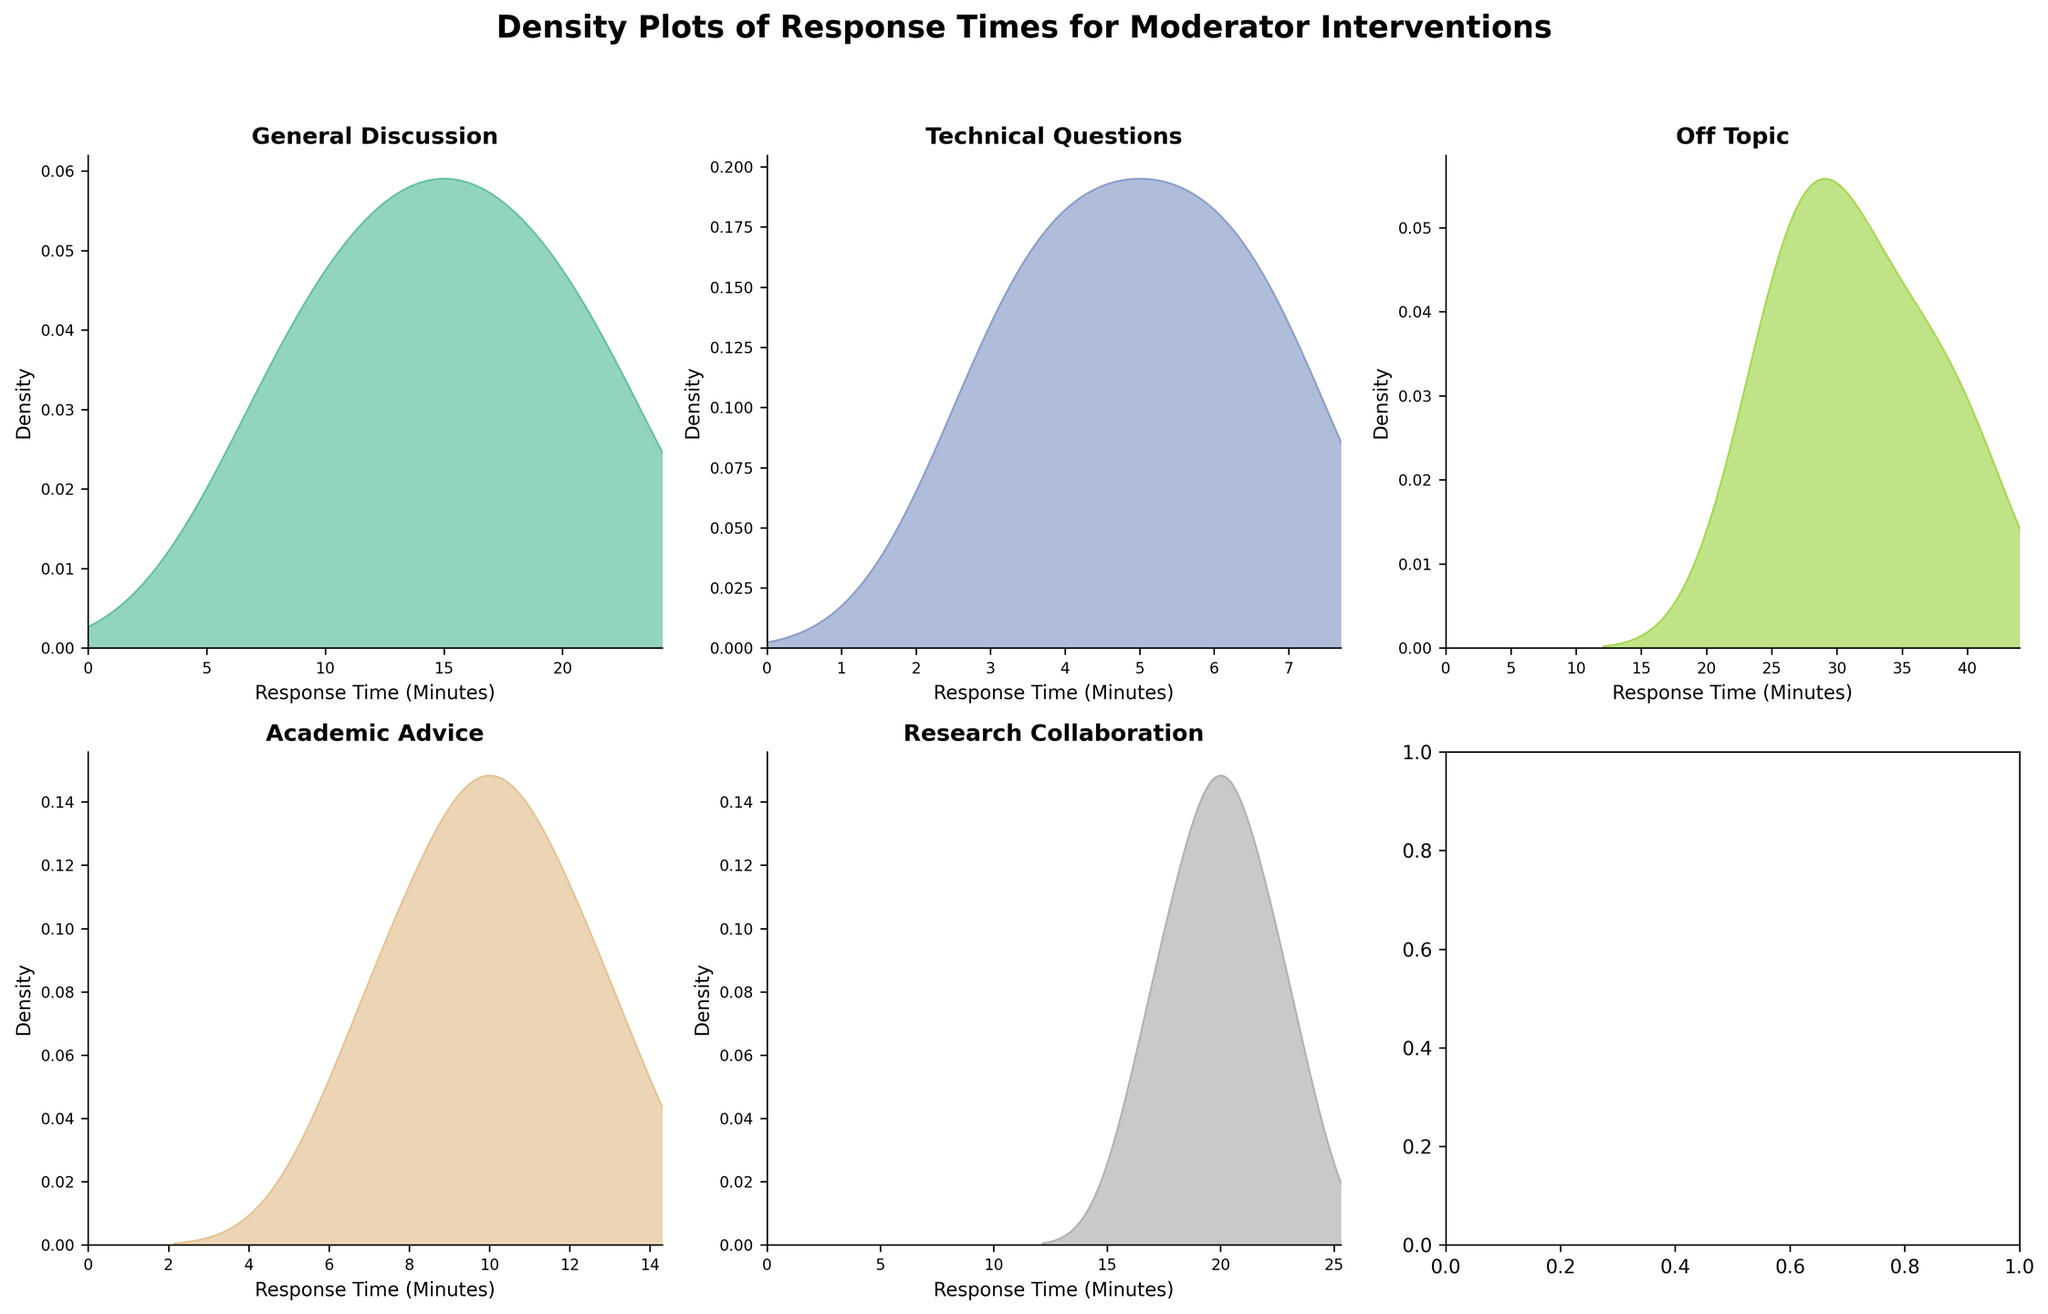What is the title of the overall figure? The figure's title is typically placed at the top and clearly explains the content being presented. By observing the top part of the figure, you will find the title "Density Plots of Response Times for Moderator Interventions".
Answer: Density Plots of Response Times for Moderator Interventions Which thread type has the widest spread of response times? To determine the thread type with the widest spread of response times, you would look for the plot with the widest horizontal range. By comparing the density plots, you'll see that the "Off Topic" thread type has response times that range from 25 to 40 minutes, indicating the widest spread among the thread types.
Answer: Off Topic How many different thread types are shown in the figure? To find the number of different thread types, count the individual plots, ensuring each subplot represents a unique thread type. The figure has a total of 6 subplots, indicating 6 different thread types.
Answer: 6 What thread type has the highest peak density? To find the highest peak density, observe which thread type's density plot reaches the highest point on the vertical axis. The "Technical Questions" thread type has the highest peak, indicating the highest density of response times around a particular value.
Answer: Technical Questions Which thread type has the shortest response time recorded? To find the shortest response time, look for the leftmost point where the density begins on each plot. The "Technical Questions" thread type's density plot starts at 3 minutes, which is the shortest recorded response time across all thread types.
Answer: Technical Questions What is the general range of response times for "General Discussion"? To determine the range, observe the horizontal span of "General Discussion" density plot. The response times range approximately from 8 to 22 minutes.
Answer: 8 to 22 minutes Which thread type has the most uniform distribution of response times? To assess uniformity, look for density plots that do not have sharp peaks and are relatively flat. The "Research Collaboration" plot appears to have a more even distribution without sharp peaks compared to others.
Answer: Research Collaboration What could be a possible mode for "Academic Advice" thread type? The mode is the most frequent value, which corresponds to the peak of the density plot. The plot for "Academic Advice" peaks around 10 minutes, indicating the mode.
Answer: 10 minutes Are there any thread types that have similar response time distributions? To determine similarity, compare the shapes and ranges of the density plots. "General Discussion" and "Academic Advice" have overlapping response time distributions, both within the 7 to 18-minute range, and similar shapes.
Answer: General Discussion and Academic Advice 